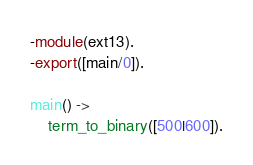Convert code to text. <code><loc_0><loc_0><loc_500><loc_500><_Erlang_>-module(ext13).
-export([main/0]).

main() ->
	term_to_binary([500|600]).
</code> 